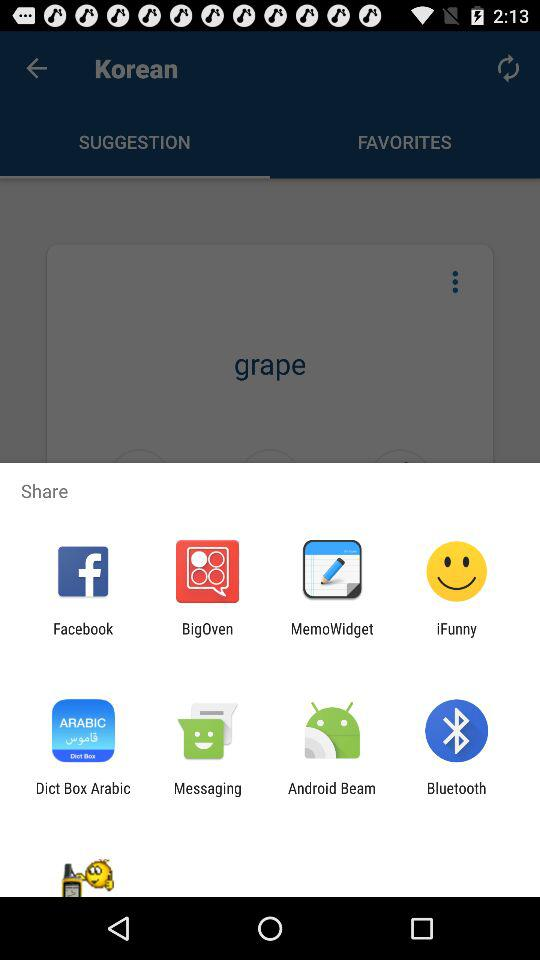Which applications can be used to share? The applications that can be used to share are "Facebook", "BigOven", "MemoWidget", "iFunny", "Dict Box Arabic", "Messaging", "Android Beam" and "Bluetooth". 